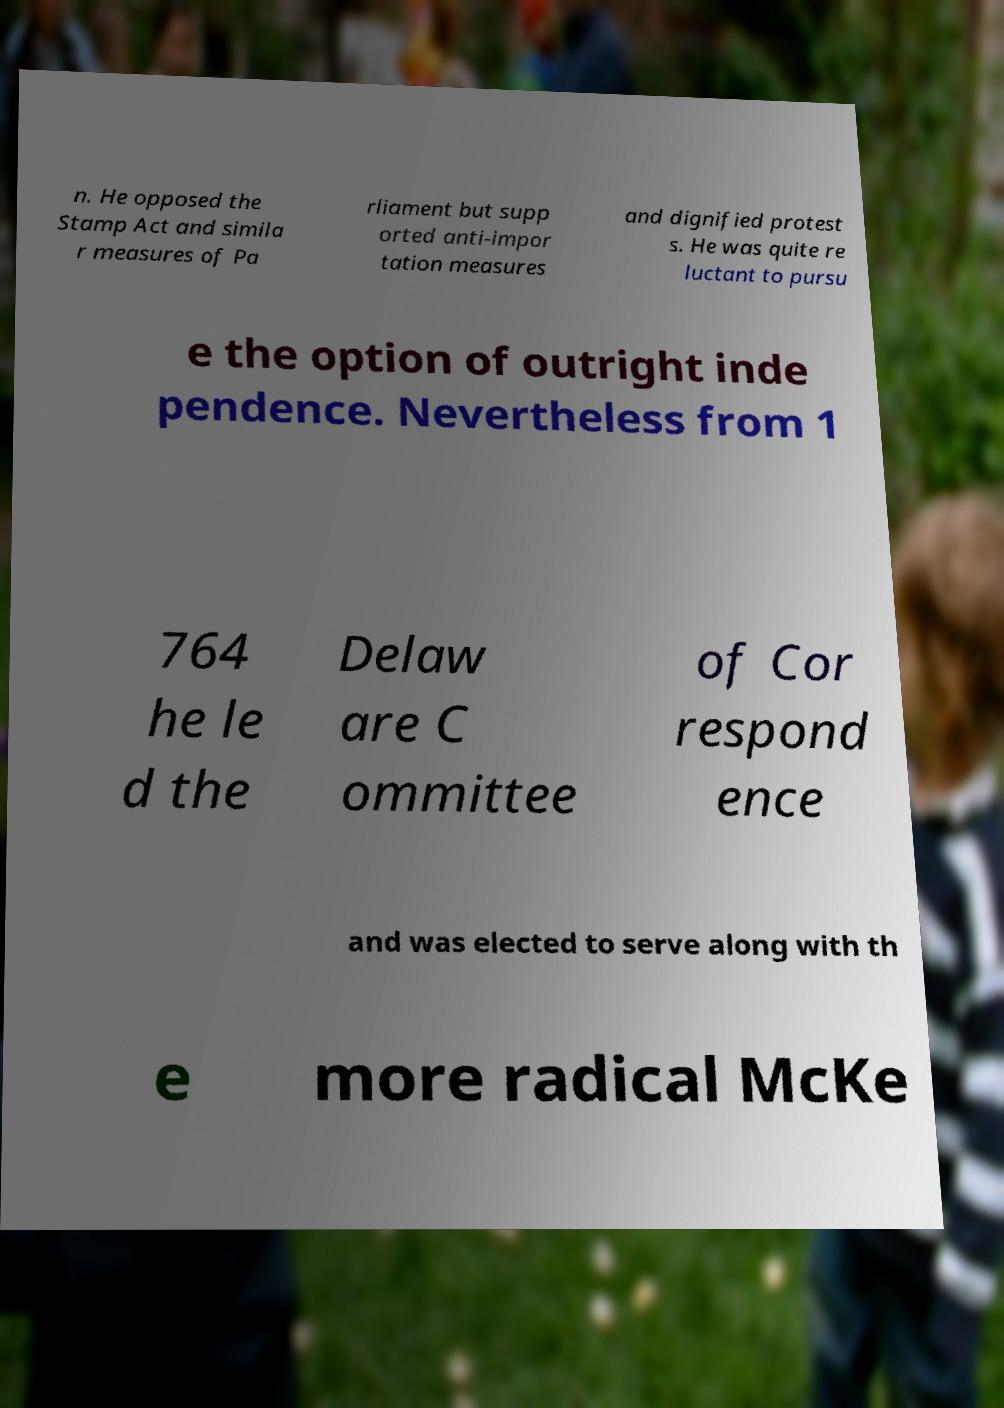Can you read and provide the text displayed in the image?This photo seems to have some interesting text. Can you extract and type it out for me? n. He opposed the Stamp Act and simila r measures of Pa rliament but supp orted anti-impor tation measures and dignified protest s. He was quite re luctant to pursu e the option of outright inde pendence. Nevertheless from 1 764 he le d the Delaw are C ommittee of Cor respond ence and was elected to serve along with th e more radical McKe 